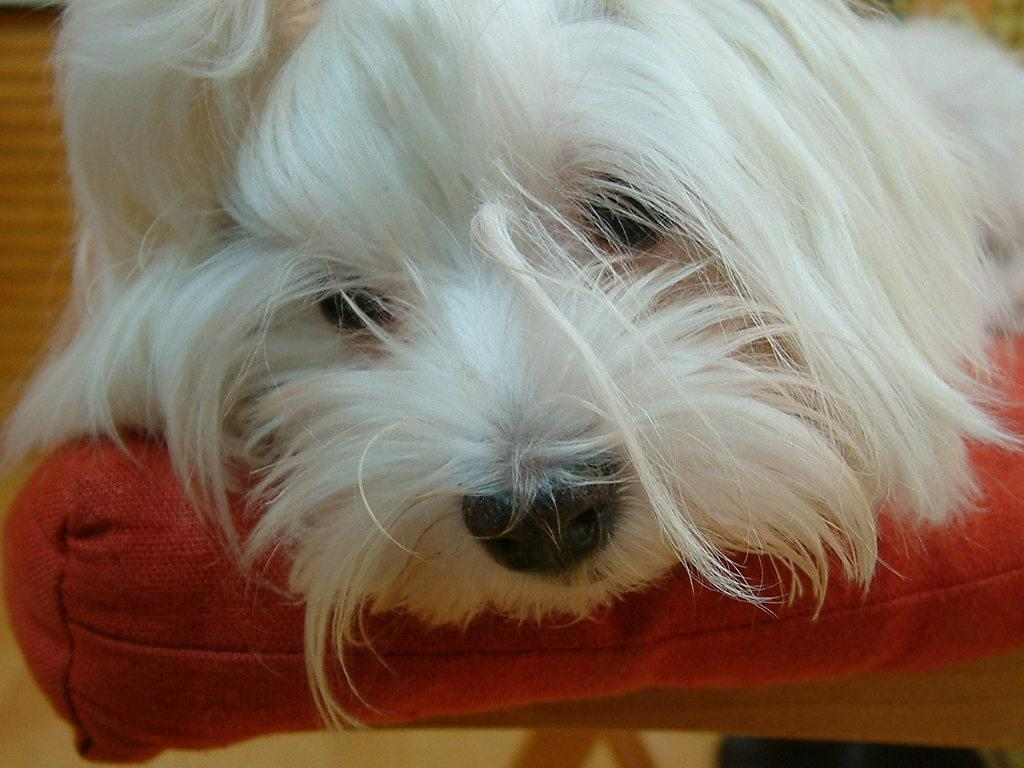What type of animal is in the image? There is a white dog in the image. Where is the dog located in the image? The dog is on a red seat. Can you describe the dog's appearance? The dog has fur on its face. What type of pest can be seen crawling on the roof in the image? There is no roof or pest present in the image; it features a white dog on a red seat. 